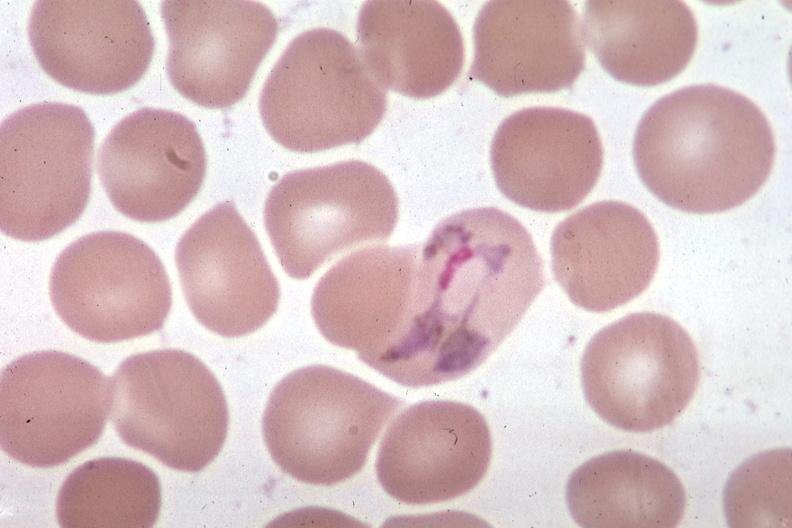what is present?
Answer the question using a single word or phrase. Malaria plasmodium vivax 